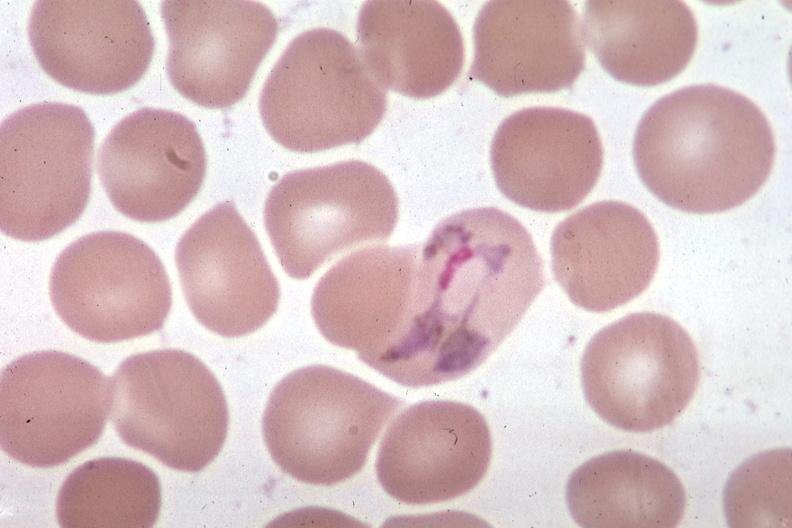what is present?
Answer the question using a single word or phrase. Malaria plasmodium vivax 